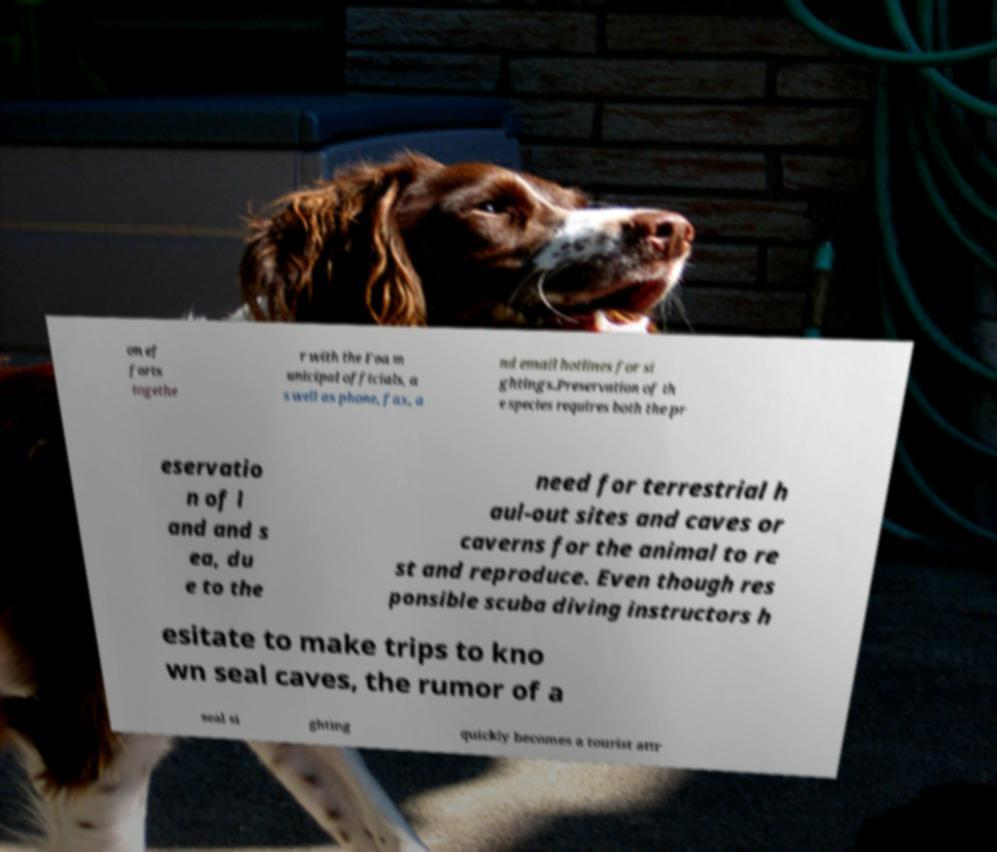Can you accurately transcribe the text from the provided image for me? on ef forts togethe r with the Foa m unicipal officials, a s well as phone, fax, a nd email hotlines for si ghtings.Preservation of th e species requires both the pr eservatio n of l and and s ea, du e to the need for terrestrial h aul-out sites and caves or caverns for the animal to re st and reproduce. Even though res ponsible scuba diving instructors h esitate to make trips to kno wn seal caves, the rumor of a seal si ghting quickly becomes a tourist attr 